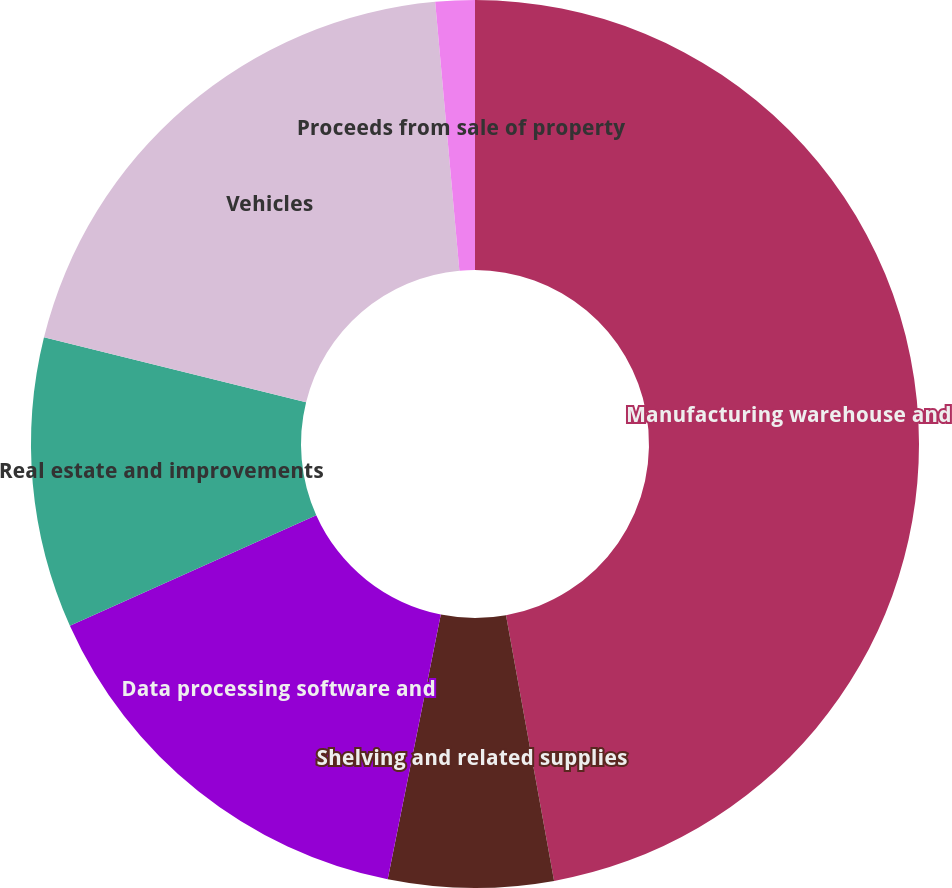<chart> <loc_0><loc_0><loc_500><loc_500><pie_chart><fcel>Manufacturing warehouse and<fcel>Shelving and related supplies<fcel>Data processing software and<fcel>Real estate and improvements<fcel>Vehicles<fcel>Proceeds from sale of property<nl><fcel>47.15%<fcel>6.0%<fcel>15.14%<fcel>10.57%<fcel>19.71%<fcel>1.43%<nl></chart> 